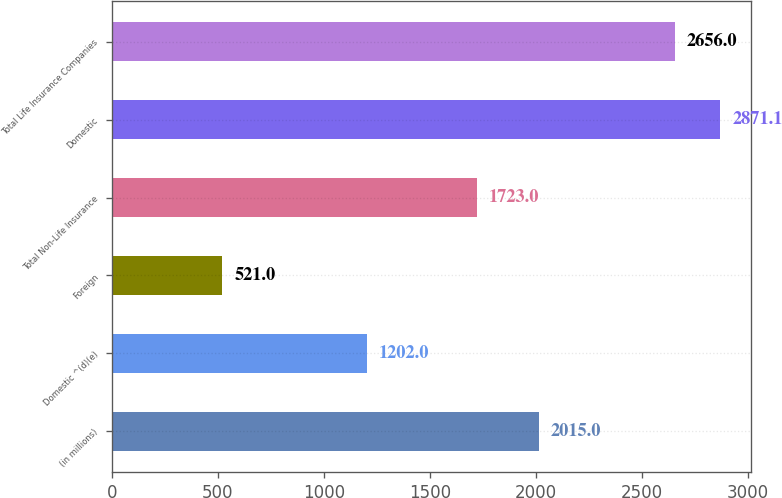Convert chart. <chart><loc_0><loc_0><loc_500><loc_500><bar_chart><fcel>(in millions)<fcel>Domestic ^(d)(e)<fcel>Foreign<fcel>Total Non-Life Insurance<fcel>Domestic<fcel>Total Life Insurance Companies<nl><fcel>2015<fcel>1202<fcel>521<fcel>1723<fcel>2871.1<fcel>2656<nl></chart> 